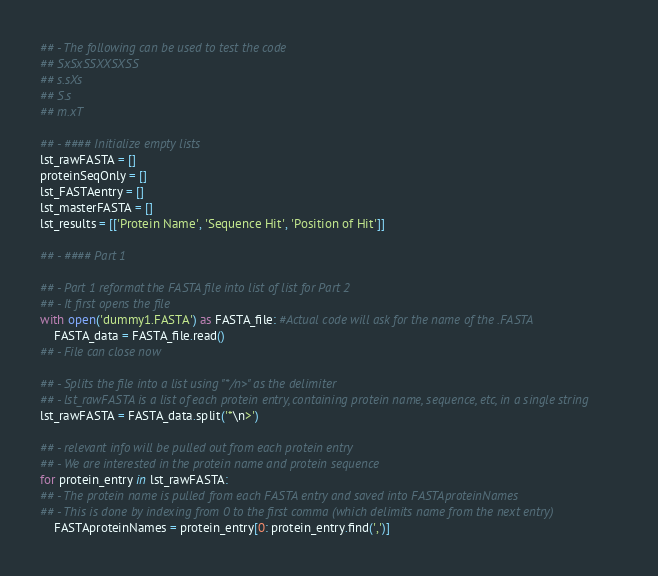Convert code to text. <code><loc_0><loc_0><loc_500><loc_500><_Python_>
## - The following can be used to test the code
## SxSxSSXXSXSS
## s.sXs
## S.s
## m.xT

## - #### Initialize empty lists
lst_rawFASTA = []
proteinSeqOnly = []
lst_FASTAentry = []
lst_masterFASTA = []
lst_results = [['Protein Name', 'Sequence Hit', 'Position of Hit']]

## - #### Part 1

## - Part 1 reformat the FASTA file into list of list for Part 2
## - It first opens the file
with open('dummy1.FASTA') as FASTA_file: #Actual code will ask for the name of the .FASTA
    FASTA_data = FASTA_file.read()
## - File can close now

## - Splits the file into a list using "*/n>" as the delimiter
## - lst_rawFASTA is a list of each protein entry, containing protein name, sequence, etc, in a single string
lst_rawFASTA = FASTA_data.split('*\n>')

## - relevant info will be pulled out from each protein entry
## - We are interested in the protein name and protein sequence
for protein_entry in lst_rawFASTA:
## - The protein name is pulled from each FASTA entry and saved into FASTAproteinNames
## - This is done by indexing from 0 to the first comma (which delimits name from the next entry)
    FASTAproteinNames = protein_entry[0: protein_entry.find(',')]
</code> 